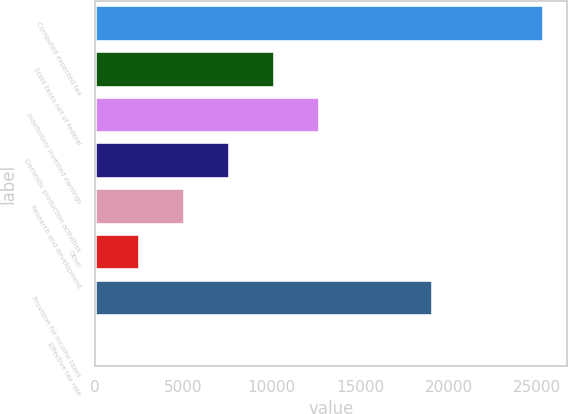Convert chart to OTSL. <chart><loc_0><loc_0><loc_500><loc_500><bar_chart><fcel>Computed expected tax<fcel>State taxes net of federal<fcel>Indefinitely invested earnings<fcel>Domestic production activities<fcel>Research and development<fcel>Other<fcel>Provision for income taxes<fcel>Effective tax rate<nl><fcel>25380<fcel>10167.8<fcel>12703.2<fcel>7632.48<fcel>5097.12<fcel>2561.76<fcel>19121<fcel>26.4<nl></chart> 